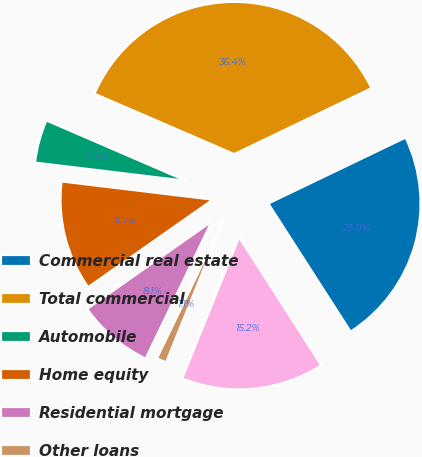Convert chart to OTSL. <chart><loc_0><loc_0><loc_500><loc_500><pie_chart><fcel>Commercial real estate<fcel>Total commercial<fcel>Automobile<fcel>Home equity<fcel>Residential mortgage<fcel>Other loans<fcel>Total consumer<nl><fcel>23.04%<fcel>36.38%<fcel>4.58%<fcel>11.65%<fcel>8.11%<fcel>1.05%<fcel>15.18%<nl></chart> 